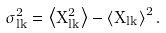Convert formula to latex. <formula><loc_0><loc_0><loc_500><loc_500>\sigma _ { l k } ^ { 2 } = \left < X _ { l k } ^ { 2 } \right > - \left < X _ { l k } \right > ^ { 2 } .</formula> 